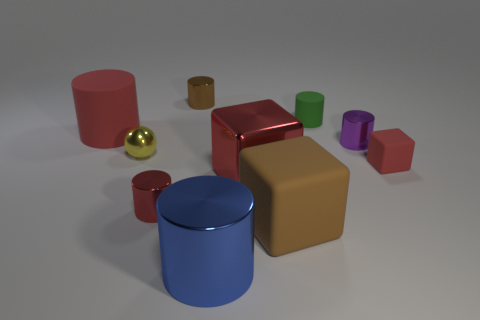There is a green thing that is made of the same material as the small red block; what shape is it?
Offer a very short reply. Cylinder. Do the matte cylinder to the right of the big blue shiny cylinder and the red rubber thing that is left of the big matte block have the same size?
Your answer should be very brief. No. What number of things are either small cylinders behind the yellow metallic ball or large gray rubber objects?
Offer a terse response. 3. Are there fewer big gray things than red things?
Make the answer very short. Yes. What shape is the small metallic thing on the left side of the tiny red thing on the left side of the shiny cylinder that is behind the big red rubber cylinder?
Ensure brevity in your answer.  Sphere. There is a shiny object that is the same color as the metal block; what is its shape?
Your response must be concise. Cylinder. Is there a yellow cylinder?
Offer a terse response. No. There is a purple metallic object; is its size the same as the matte cylinder that is to the left of the small green cylinder?
Your answer should be compact. No. Are there any red cubes right of the red cylinder that is in front of the red rubber cylinder?
Offer a terse response. Yes. What is the material of the large object that is to the right of the brown shiny object and behind the big brown cube?
Ensure brevity in your answer.  Metal. 